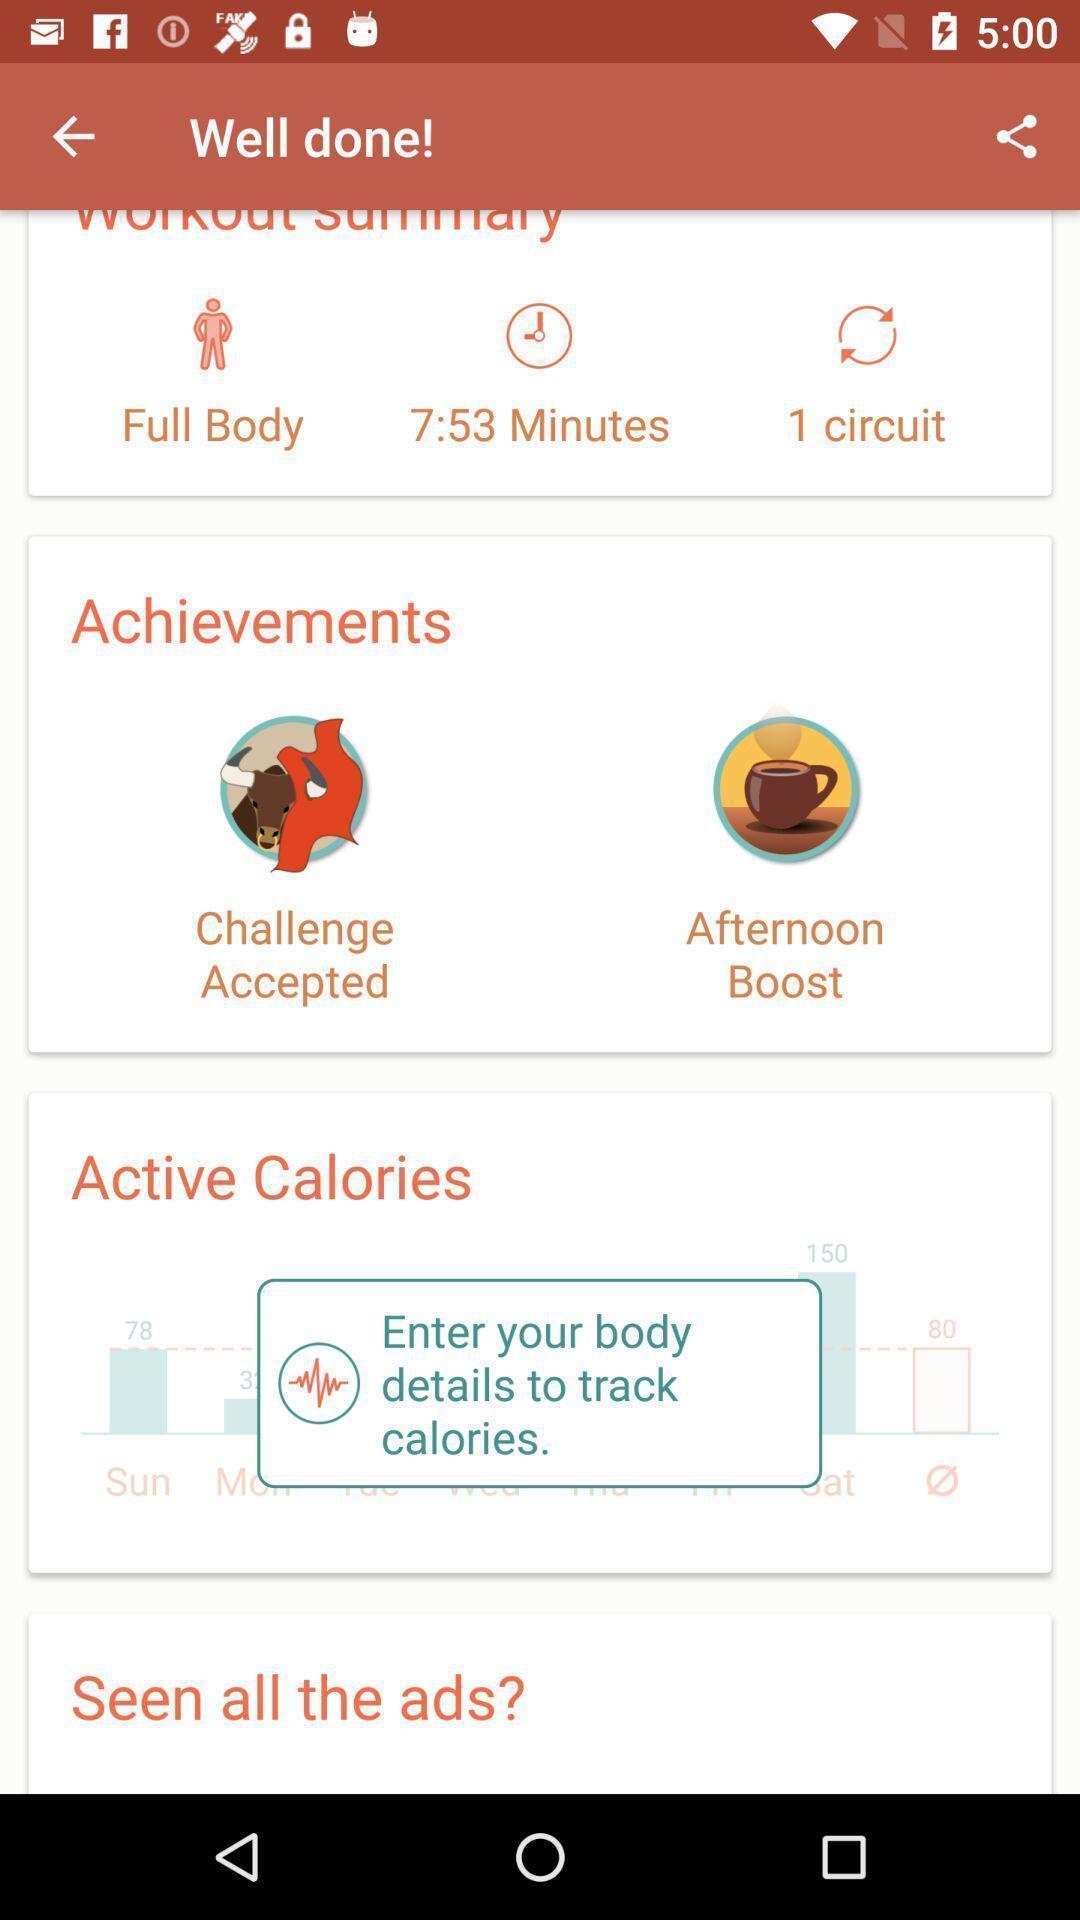What is the overall content of this screenshot? Pop up page showing the enter details to track. 